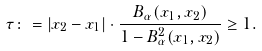Convert formula to latex. <formula><loc_0><loc_0><loc_500><loc_500>\tau \colon = | x _ { 2 } - x _ { 1 } | \cdot \frac { B _ { \alpha } ( x _ { 1 } , x _ { 2 } ) } { 1 - B _ { \alpha } ^ { 2 } ( x _ { 1 } , x _ { 2 } ) } \geq 1 .</formula> 